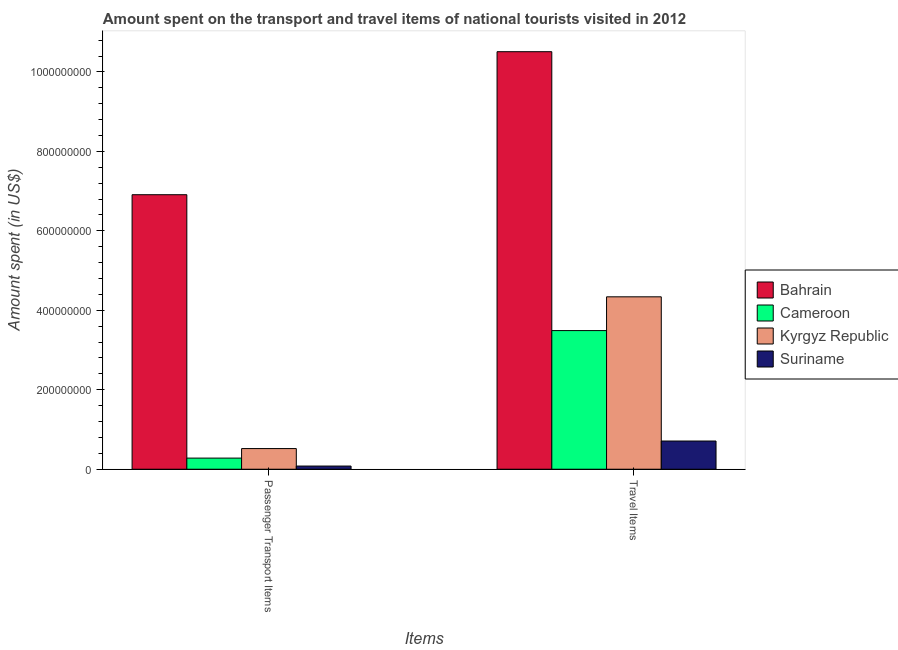How many different coloured bars are there?
Ensure brevity in your answer.  4. Are the number of bars on each tick of the X-axis equal?
Give a very brief answer. Yes. What is the label of the 1st group of bars from the left?
Your response must be concise. Passenger Transport Items. What is the amount spent on passenger transport items in Kyrgyz Republic?
Make the answer very short. 5.20e+07. Across all countries, what is the maximum amount spent on passenger transport items?
Provide a succinct answer. 6.91e+08. Across all countries, what is the minimum amount spent in travel items?
Make the answer very short. 7.10e+07. In which country was the amount spent in travel items maximum?
Provide a succinct answer. Bahrain. In which country was the amount spent in travel items minimum?
Your answer should be compact. Suriname. What is the total amount spent in travel items in the graph?
Provide a short and direct response. 1.90e+09. What is the difference between the amount spent on passenger transport items in Cameroon and that in Bahrain?
Ensure brevity in your answer.  -6.63e+08. What is the difference between the amount spent in travel items in Kyrgyz Republic and the amount spent on passenger transport items in Bahrain?
Provide a succinct answer. -2.57e+08. What is the average amount spent on passenger transport items per country?
Your answer should be compact. 1.95e+08. What is the difference between the amount spent on passenger transport items and amount spent in travel items in Kyrgyz Republic?
Make the answer very short. -3.82e+08. In how many countries, is the amount spent on passenger transport items greater than 120000000 US$?
Your answer should be compact. 1. What is the ratio of the amount spent in travel items in Cameroon to that in Suriname?
Your answer should be very brief. 4.92. In how many countries, is the amount spent on passenger transport items greater than the average amount spent on passenger transport items taken over all countries?
Offer a terse response. 1. What does the 4th bar from the left in Passenger Transport Items represents?
Your response must be concise. Suriname. What does the 4th bar from the right in Passenger Transport Items represents?
Offer a terse response. Bahrain. How many countries are there in the graph?
Your answer should be very brief. 4. Are the values on the major ticks of Y-axis written in scientific E-notation?
Offer a terse response. No. Does the graph contain grids?
Ensure brevity in your answer.  No. What is the title of the graph?
Give a very brief answer. Amount spent on the transport and travel items of national tourists visited in 2012. Does "Singapore" appear as one of the legend labels in the graph?
Keep it short and to the point. No. What is the label or title of the X-axis?
Provide a short and direct response. Items. What is the label or title of the Y-axis?
Offer a very short reply. Amount spent (in US$). What is the Amount spent (in US$) of Bahrain in Passenger Transport Items?
Make the answer very short. 6.91e+08. What is the Amount spent (in US$) of Cameroon in Passenger Transport Items?
Your answer should be very brief. 2.80e+07. What is the Amount spent (in US$) in Kyrgyz Republic in Passenger Transport Items?
Provide a succinct answer. 5.20e+07. What is the Amount spent (in US$) in Bahrain in Travel Items?
Give a very brief answer. 1.05e+09. What is the Amount spent (in US$) in Cameroon in Travel Items?
Offer a terse response. 3.49e+08. What is the Amount spent (in US$) in Kyrgyz Republic in Travel Items?
Your response must be concise. 4.34e+08. What is the Amount spent (in US$) in Suriname in Travel Items?
Your response must be concise. 7.10e+07. Across all Items, what is the maximum Amount spent (in US$) in Bahrain?
Your response must be concise. 1.05e+09. Across all Items, what is the maximum Amount spent (in US$) in Cameroon?
Offer a very short reply. 3.49e+08. Across all Items, what is the maximum Amount spent (in US$) of Kyrgyz Republic?
Offer a terse response. 4.34e+08. Across all Items, what is the maximum Amount spent (in US$) in Suriname?
Offer a very short reply. 7.10e+07. Across all Items, what is the minimum Amount spent (in US$) in Bahrain?
Give a very brief answer. 6.91e+08. Across all Items, what is the minimum Amount spent (in US$) of Cameroon?
Ensure brevity in your answer.  2.80e+07. Across all Items, what is the minimum Amount spent (in US$) in Kyrgyz Republic?
Your answer should be very brief. 5.20e+07. What is the total Amount spent (in US$) of Bahrain in the graph?
Provide a short and direct response. 1.74e+09. What is the total Amount spent (in US$) of Cameroon in the graph?
Keep it short and to the point. 3.77e+08. What is the total Amount spent (in US$) of Kyrgyz Republic in the graph?
Keep it short and to the point. 4.86e+08. What is the total Amount spent (in US$) in Suriname in the graph?
Make the answer very short. 7.90e+07. What is the difference between the Amount spent (in US$) in Bahrain in Passenger Transport Items and that in Travel Items?
Keep it short and to the point. -3.60e+08. What is the difference between the Amount spent (in US$) in Cameroon in Passenger Transport Items and that in Travel Items?
Ensure brevity in your answer.  -3.21e+08. What is the difference between the Amount spent (in US$) of Kyrgyz Republic in Passenger Transport Items and that in Travel Items?
Keep it short and to the point. -3.82e+08. What is the difference between the Amount spent (in US$) of Suriname in Passenger Transport Items and that in Travel Items?
Make the answer very short. -6.30e+07. What is the difference between the Amount spent (in US$) in Bahrain in Passenger Transport Items and the Amount spent (in US$) in Cameroon in Travel Items?
Offer a very short reply. 3.42e+08. What is the difference between the Amount spent (in US$) of Bahrain in Passenger Transport Items and the Amount spent (in US$) of Kyrgyz Republic in Travel Items?
Ensure brevity in your answer.  2.57e+08. What is the difference between the Amount spent (in US$) of Bahrain in Passenger Transport Items and the Amount spent (in US$) of Suriname in Travel Items?
Make the answer very short. 6.20e+08. What is the difference between the Amount spent (in US$) of Cameroon in Passenger Transport Items and the Amount spent (in US$) of Kyrgyz Republic in Travel Items?
Offer a very short reply. -4.06e+08. What is the difference between the Amount spent (in US$) in Cameroon in Passenger Transport Items and the Amount spent (in US$) in Suriname in Travel Items?
Your answer should be very brief. -4.30e+07. What is the difference between the Amount spent (in US$) in Kyrgyz Republic in Passenger Transport Items and the Amount spent (in US$) in Suriname in Travel Items?
Give a very brief answer. -1.90e+07. What is the average Amount spent (in US$) of Bahrain per Items?
Provide a short and direct response. 8.71e+08. What is the average Amount spent (in US$) of Cameroon per Items?
Your response must be concise. 1.88e+08. What is the average Amount spent (in US$) of Kyrgyz Republic per Items?
Your response must be concise. 2.43e+08. What is the average Amount spent (in US$) in Suriname per Items?
Keep it short and to the point. 3.95e+07. What is the difference between the Amount spent (in US$) in Bahrain and Amount spent (in US$) in Cameroon in Passenger Transport Items?
Your response must be concise. 6.63e+08. What is the difference between the Amount spent (in US$) of Bahrain and Amount spent (in US$) of Kyrgyz Republic in Passenger Transport Items?
Offer a very short reply. 6.39e+08. What is the difference between the Amount spent (in US$) of Bahrain and Amount spent (in US$) of Suriname in Passenger Transport Items?
Offer a terse response. 6.83e+08. What is the difference between the Amount spent (in US$) in Cameroon and Amount spent (in US$) in Kyrgyz Republic in Passenger Transport Items?
Provide a short and direct response. -2.40e+07. What is the difference between the Amount spent (in US$) of Kyrgyz Republic and Amount spent (in US$) of Suriname in Passenger Transport Items?
Provide a succinct answer. 4.40e+07. What is the difference between the Amount spent (in US$) of Bahrain and Amount spent (in US$) of Cameroon in Travel Items?
Offer a very short reply. 7.02e+08. What is the difference between the Amount spent (in US$) of Bahrain and Amount spent (in US$) of Kyrgyz Republic in Travel Items?
Provide a short and direct response. 6.17e+08. What is the difference between the Amount spent (in US$) of Bahrain and Amount spent (in US$) of Suriname in Travel Items?
Give a very brief answer. 9.80e+08. What is the difference between the Amount spent (in US$) in Cameroon and Amount spent (in US$) in Kyrgyz Republic in Travel Items?
Offer a terse response. -8.50e+07. What is the difference between the Amount spent (in US$) in Cameroon and Amount spent (in US$) in Suriname in Travel Items?
Make the answer very short. 2.78e+08. What is the difference between the Amount spent (in US$) in Kyrgyz Republic and Amount spent (in US$) in Suriname in Travel Items?
Provide a short and direct response. 3.63e+08. What is the ratio of the Amount spent (in US$) of Bahrain in Passenger Transport Items to that in Travel Items?
Give a very brief answer. 0.66. What is the ratio of the Amount spent (in US$) of Cameroon in Passenger Transport Items to that in Travel Items?
Offer a very short reply. 0.08. What is the ratio of the Amount spent (in US$) in Kyrgyz Republic in Passenger Transport Items to that in Travel Items?
Give a very brief answer. 0.12. What is the ratio of the Amount spent (in US$) in Suriname in Passenger Transport Items to that in Travel Items?
Your answer should be very brief. 0.11. What is the difference between the highest and the second highest Amount spent (in US$) in Bahrain?
Keep it short and to the point. 3.60e+08. What is the difference between the highest and the second highest Amount spent (in US$) of Cameroon?
Offer a very short reply. 3.21e+08. What is the difference between the highest and the second highest Amount spent (in US$) of Kyrgyz Republic?
Provide a succinct answer. 3.82e+08. What is the difference between the highest and the second highest Amount spent (in US$) of Suriname?
Your answer should be compact. 6.30e+07. What is the difference between the highest and the lowest Amount spent (in US$) in Bahrain?
Your response must be concise. 3.60e+08. What is the difference between the highest and the lowest Amount spent (in US$) of Cameroon?
Your answer should be very brief. 3.21e+08. What is the difference between the highest and the lowest Amount spent (in US$) of Kyrgyz Republic?
Give a very brief answer. 3.82e+08. What is the difference between the highest and the lowest Amount spent (in US$) of Suriname?
Provide a succinct answer. 6.30e+07. 